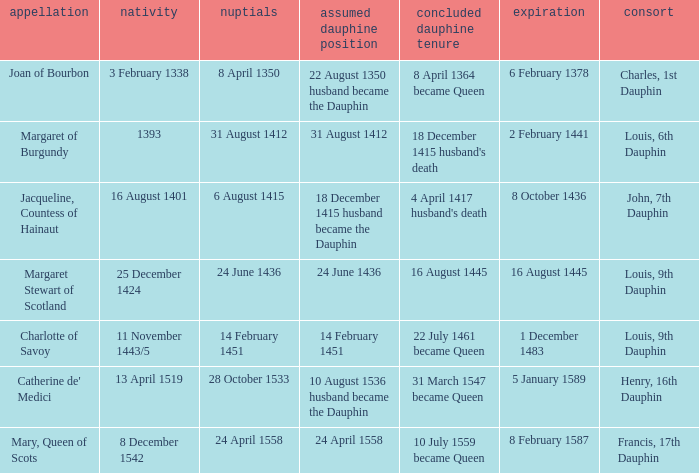Who has a birth of 16 august 1401? Jacqueline, Countess of Hainaut. 